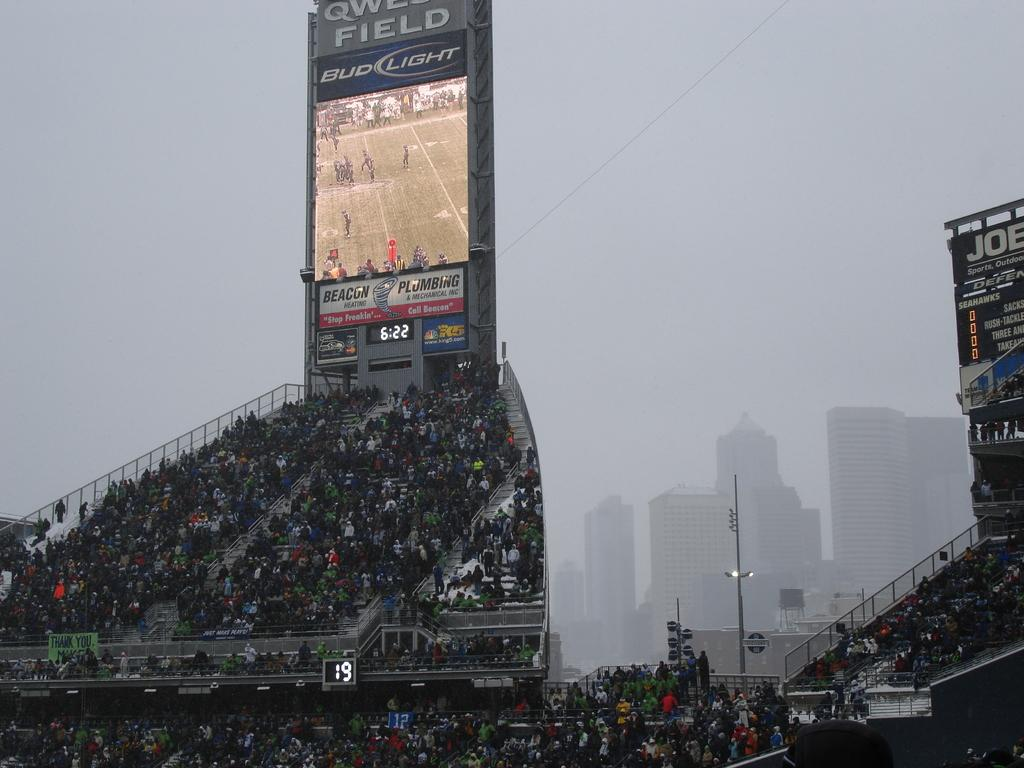<image>
Write a terse but informative summary of the picture. Bud light is a sponsor for one of the big screens at the ball field 